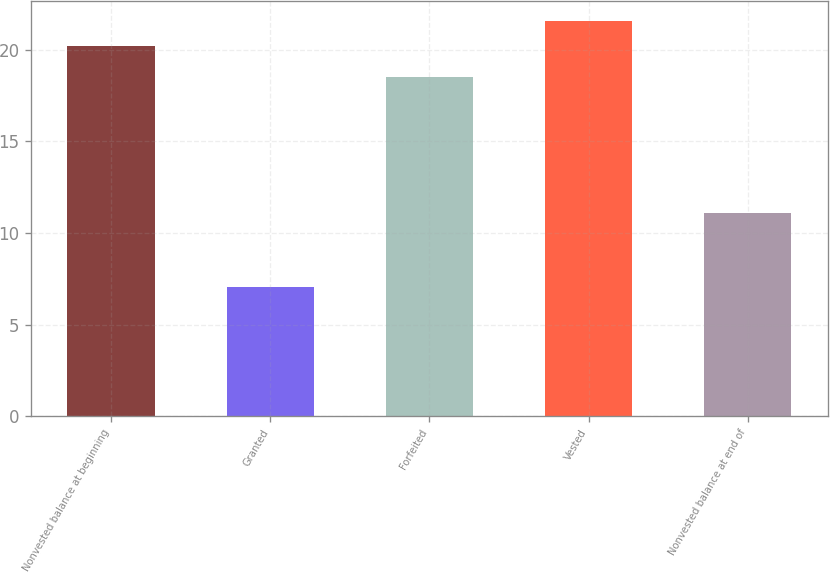<chart> <loc_0><loc_0><loc_500><loc_500><bar_chart><fcel>Nonvested balance at beginning<fcel>Granted<fcel>Forfeited<fcel>Vested<fcel>Nonvested balance at end of<nl><fcel>20.2<fcel>7.06<fcel>18.52<fcel>21.58<fcel>11.09<nl></chart> 